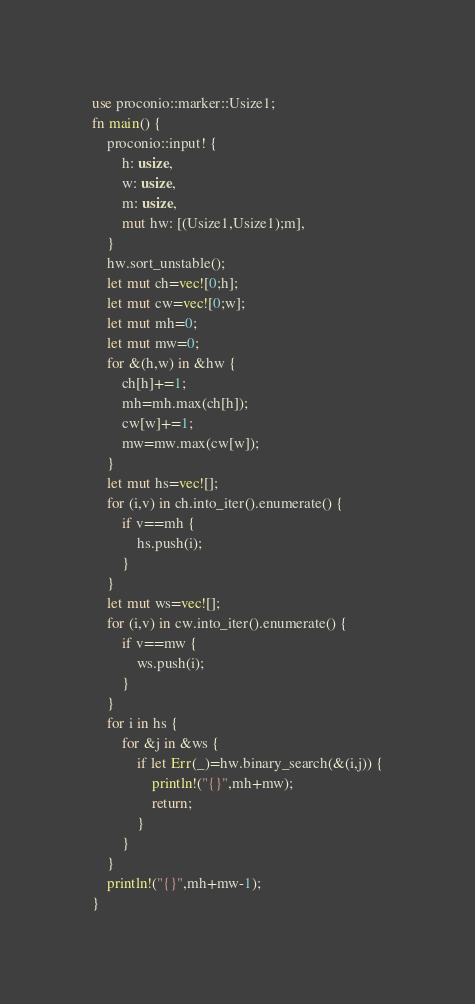Convert code to text. <code><loc_0><loc_0><loc_500><loc_500><_Rust_>use proconio::marker::Usize1;
fn main() {
    proconio::input! {
        h: usize,
        w: usize,
        m: usize,
        mut hw: [(Usize1,Usize1);m],
    }
    hw.sort_unstable();
    let mut ch=vec![0;h];
    let mut cw=vec![0;w];
    let mut mh=0;
    let mut mw=0;
    for &(h,w) in &hw {
        ch[h]+=1;
        mh=mh.max(ch[h]);
        cw[w]+=1;
        mw=mw.max(cw[w]);
    }
    let mut hs=vec![];
    for (i,v) in ch.into_iter().enumerate() {
        if v==mh {
            hs.push(i);
        }
    }
    let mut ws=vec![];
    for (i,v) in cw.into_iter().enumerate() {
        if v==mw {
            ws.push(i);
        }
    }
    for i in hs {
        for &j in &ws {
            if let Err(_)=hw.binary_search(&(i,j)) {
                println!("{}",mh+mw);
                return;
            }
        }
    }
    println!("{}",mh+mw-1);
}
</code> 